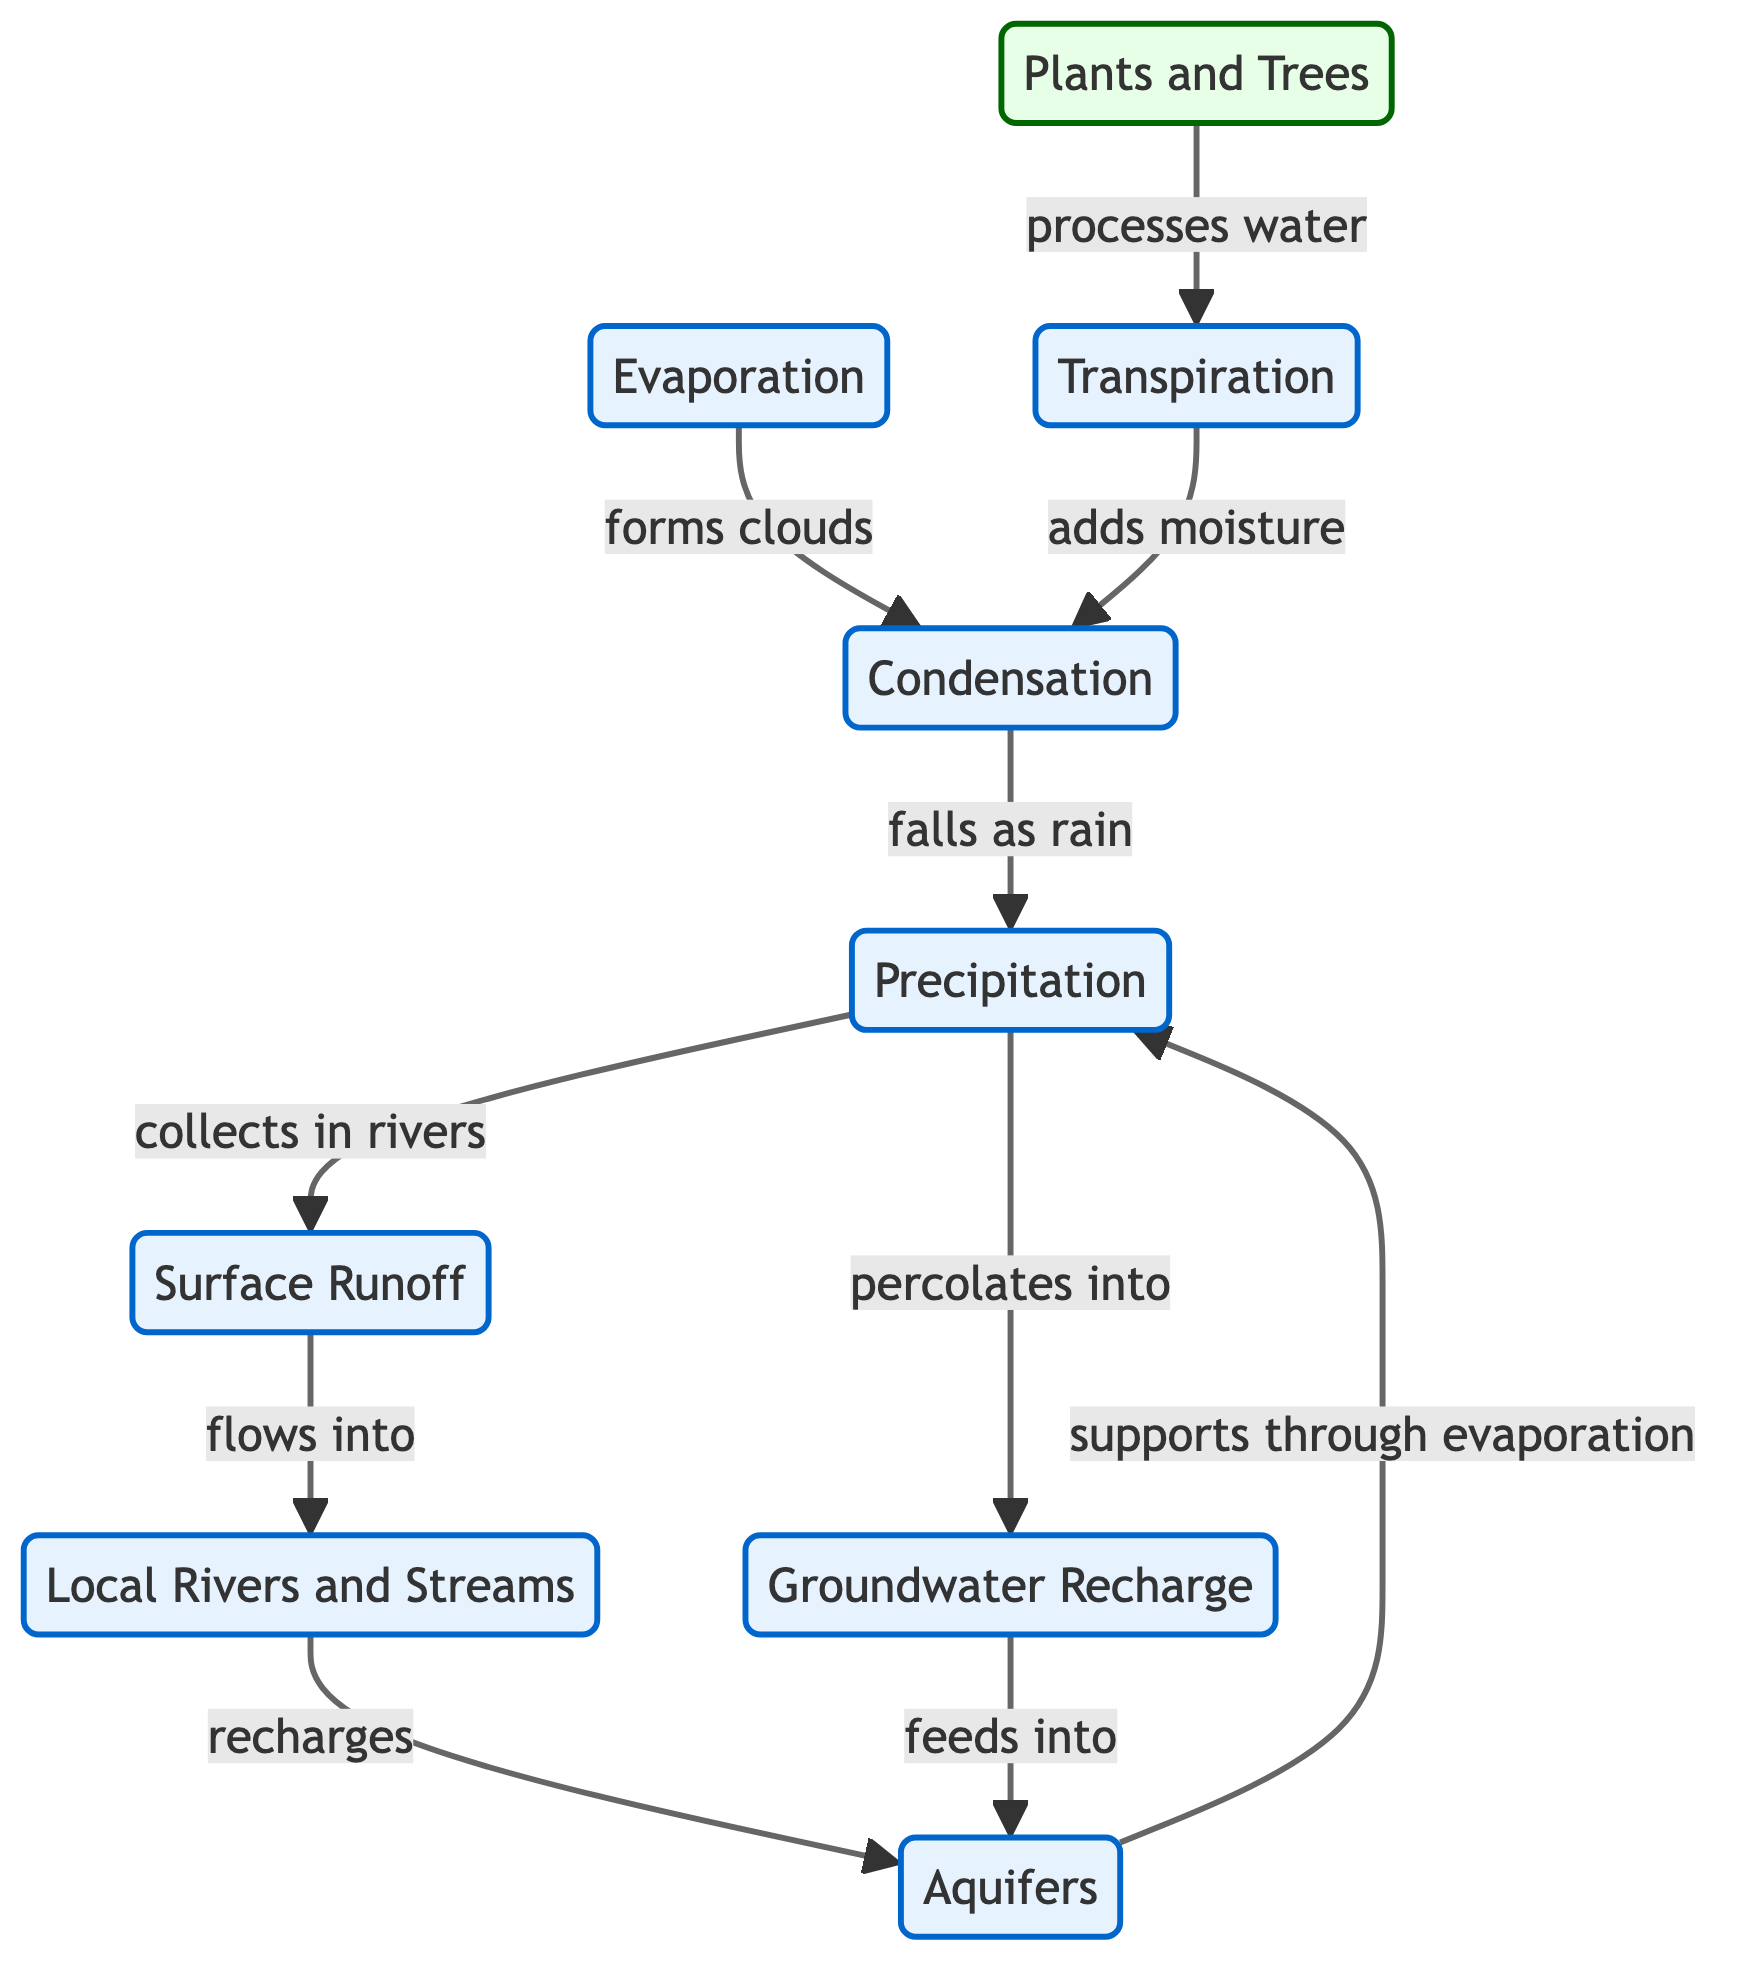What is the main process that leads to precipitation? The diagram indicates that precipitation is formed through condensation, which is represented as an arrow flowing from condensation to precipitation. Thus, condensation is the key process leading to precipitation.
Answer: condensation Which element adds moisture to condensation? According to the diagram, transpiration is the process that adds moisture to condensation, as shown by the arrow pointing from transpiration to condensation.
Answer: transpiration How many main processes are represented in the diagram? By counting the labeled elements, there are six main processes depicted: Precipitation, Evaporation, Transpiration, Condensation, Surface Runoff, and Groundwater Recharge.
Answer: six What relationship exists between local rivers and aquifers? The diagram shows that local rivers recharge aquifers, creating a direct relationship as indicated by the arrow flowing from local rivers to aquifers.
Answer: recharges Which process occurs as water evaporates from plants? They represent the process of transpiration, which the diagram shows as an arrow indicating that plants process water, leading to transpiration.
Answer: transpiration What journey does water take after precipitation? After precipitation, the water collects in rivers and eventually flows into local rivers, then recharges aquifers, creating a series of steps. This flow can be summarized as: collects in rivers → flows into local rivers → recharges aquifers.
Answer: collects in rivers, flows into local rivers, recharges aquifers Which two processes lead to the formation of precipitation? The two processes leading to the formation of precipitation are evaporation and condensation, as shown by the connections leading towards precipitation. Evaporation forms clouds that eventually lead to precipitation through condensation.
Answer: evaporation, condensation Which component directly supports transpiration? The component that directly supports transpiration is plants, as indicated by the diagram showing a flow from plants to transpiration.
Answer: plants 